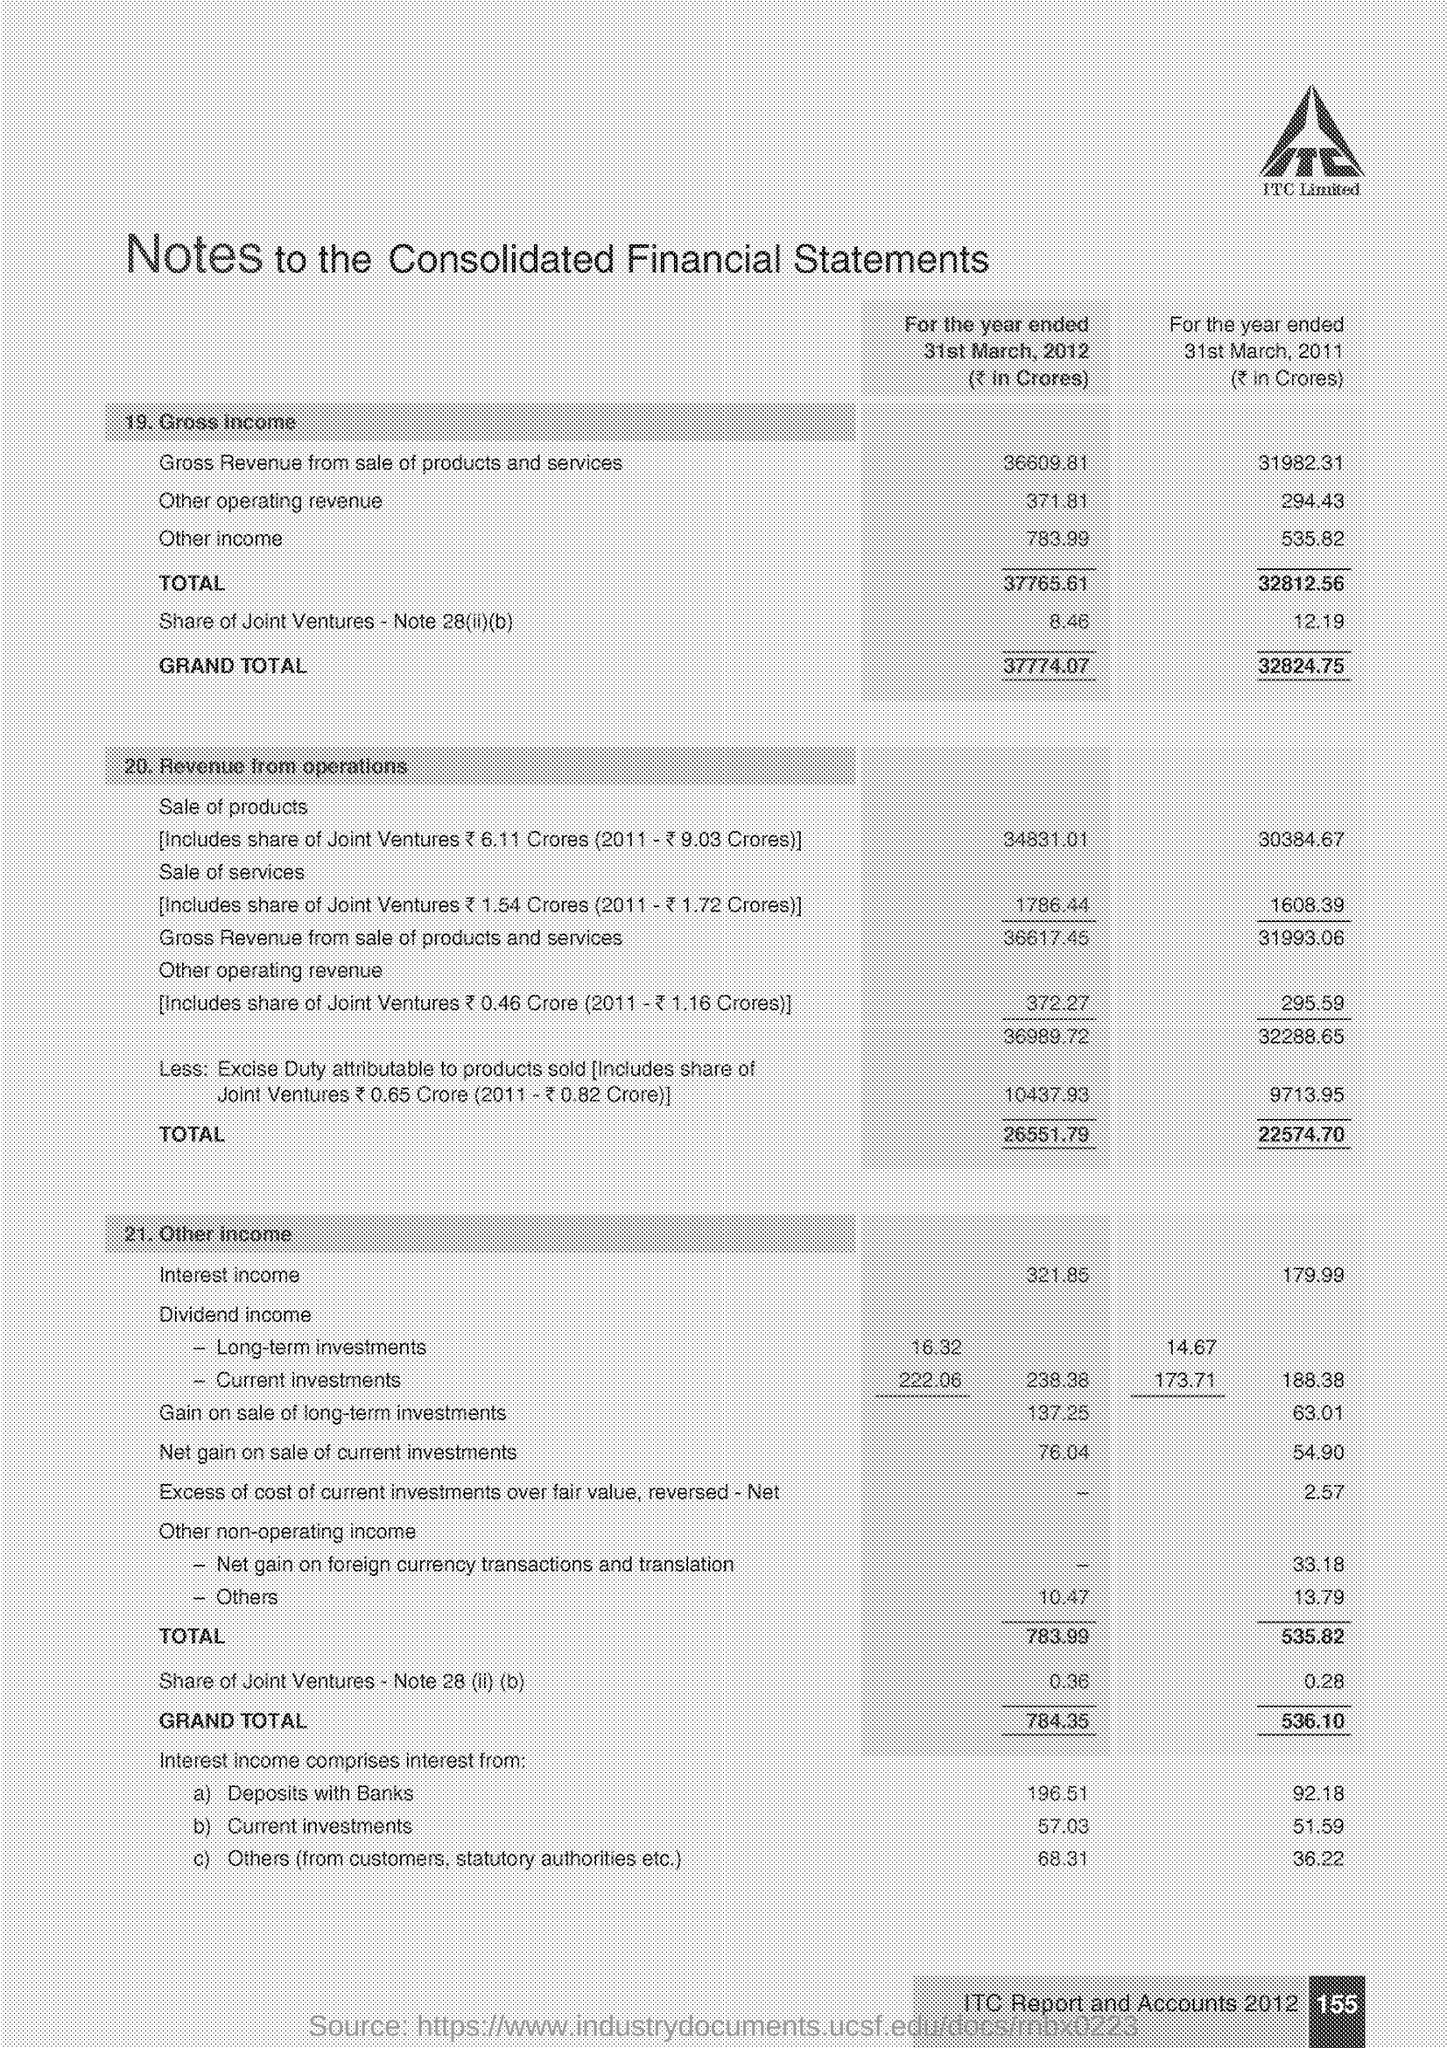Highlight a few significant elements in this photo. The company name is Itc Limited. 